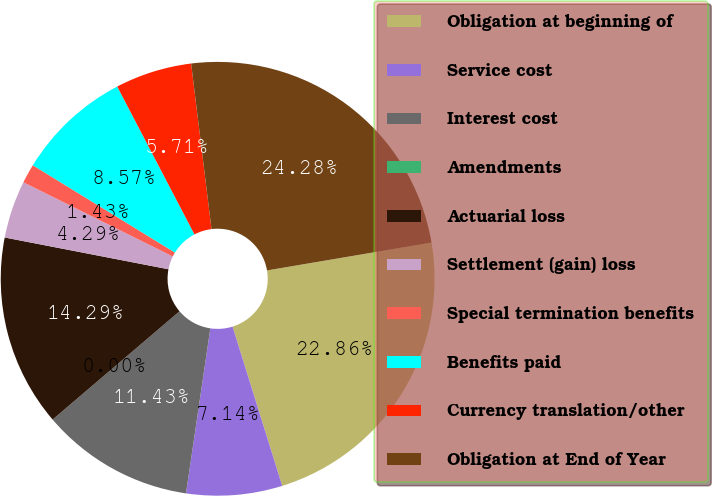<chart> <loc_0><loc_0><loc_500><loc_500><pie_chart><fcel>Obligation at beginning of<fcel>Service cost<fcel>Interest cost<fcel>Amendments<fcel>Actuarial loss<fcel>Settlement (gain) loss<fcel>Special termination benefits<fcel>Benefits paid<fcel>Currency translation/other<fcel>Obligation at End of Year<nl><fcel>22.86%<fcel>7.14%<fcel>11.43%<fcel>0.0%<fcel>14.29%<fcel>4.29%<fcel>1.43%<fcel>8.57%<fcel>5.71%<fcel>24.28%<nl></chart> 